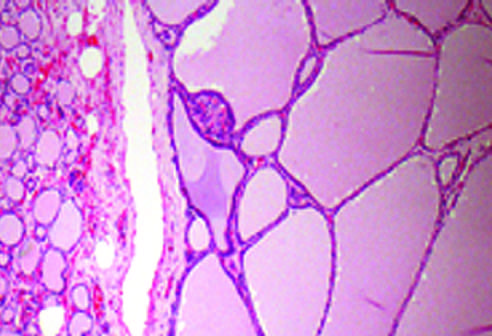what do the hyperplastic follicles contain?
Answer the question using a single word or phrase. Abundant pink colloid within their lumina 